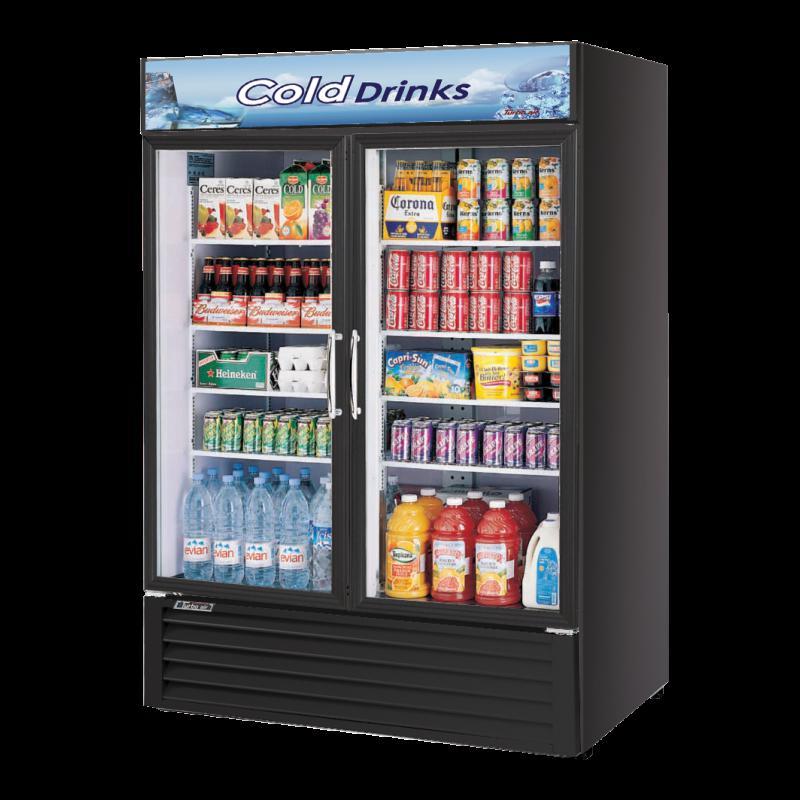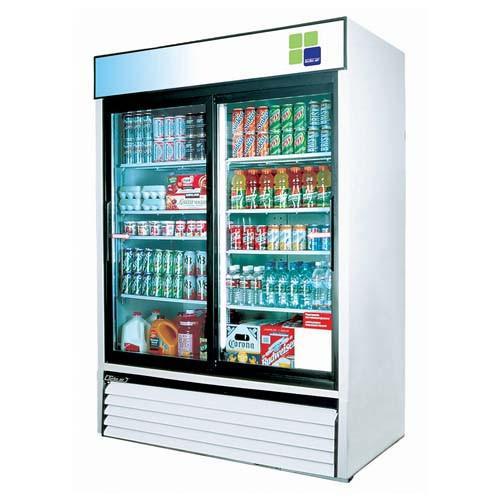The first image is the image on the left, the second image is the image on the right. Evaluate the accuracy of this statement regarding the images: "One image features a vending machine with an undivided band of three colors across the top.". Is it true? Answer yes or no. No. The first image is the image on the left, the second image is the image on the right. For the images displayed, is the sentence "Two vending machines are white with black trim and two large glass doors, but one has one set of three wide color stripes at the top, while the other has two sets of narrower color stripes." factually correct? Answer yes or no. No. 